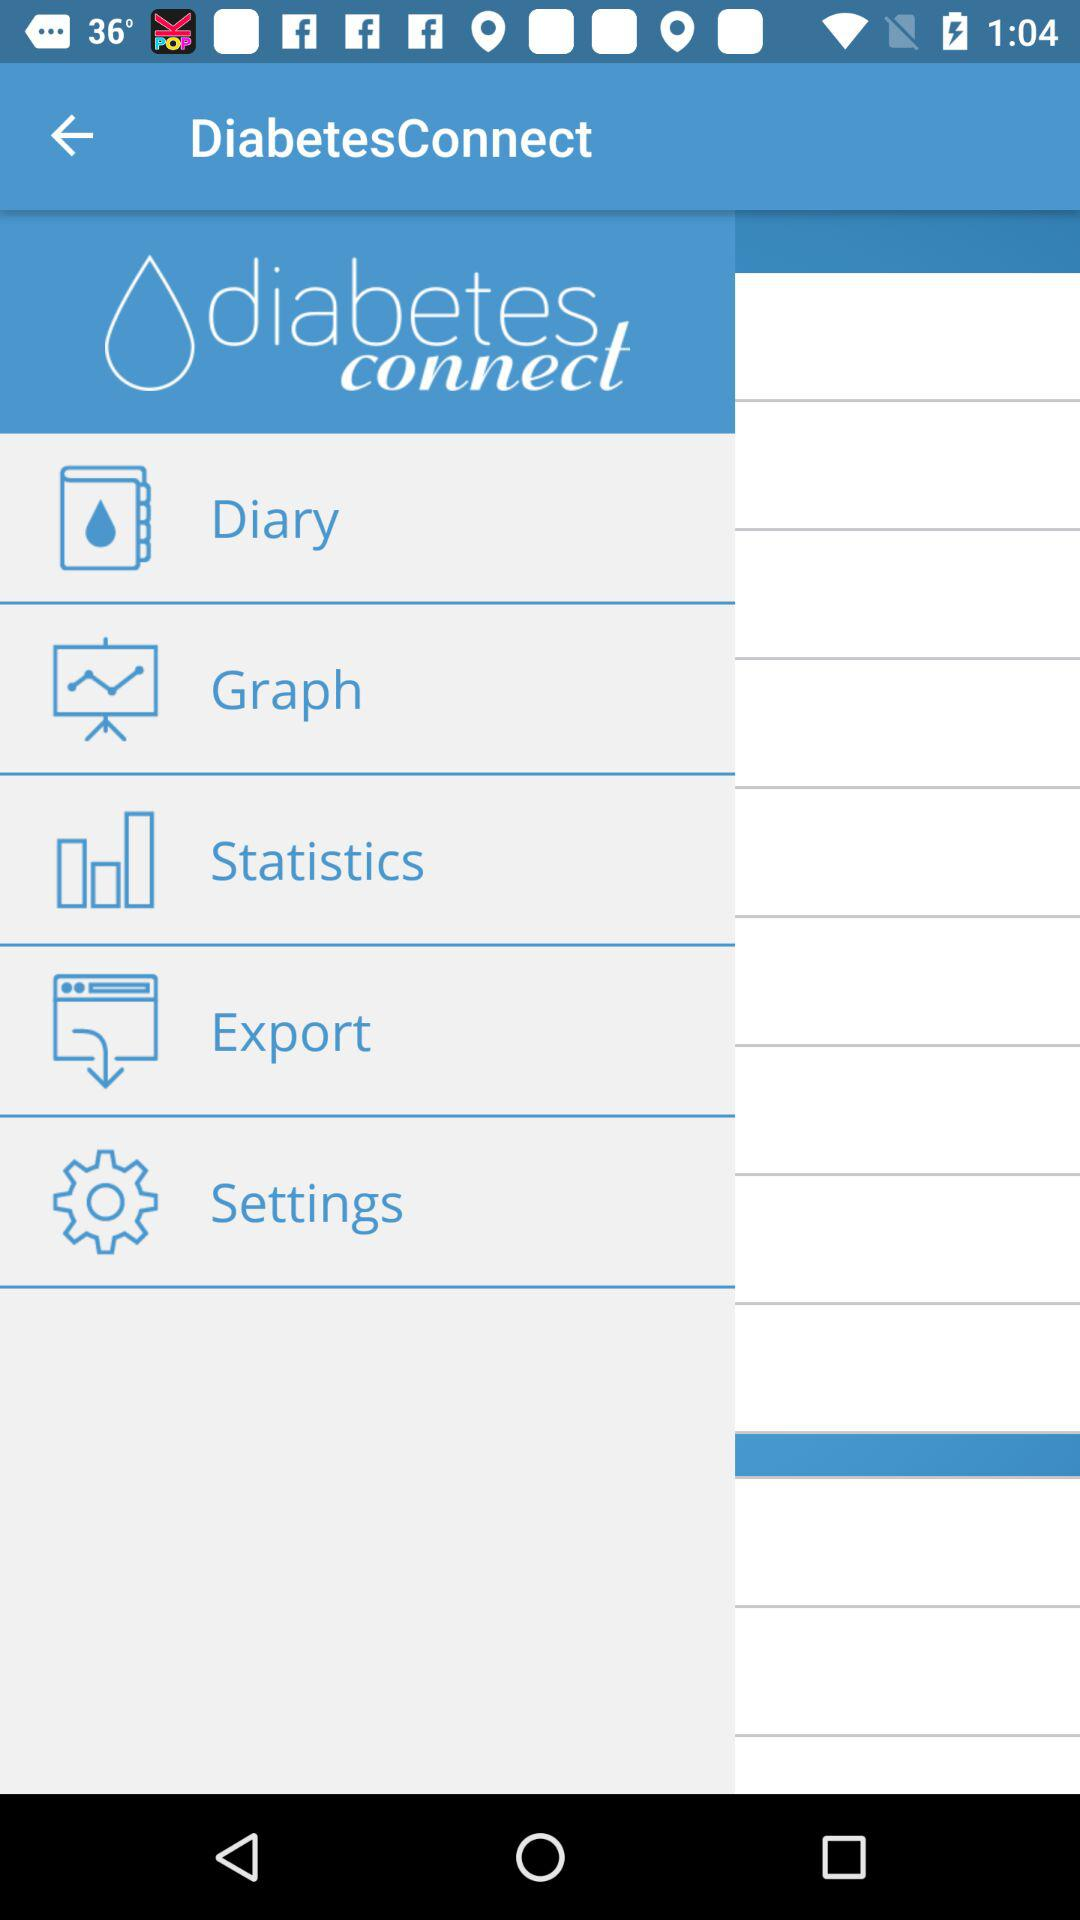What is the app name? The app name is "DiabetesConnect". 